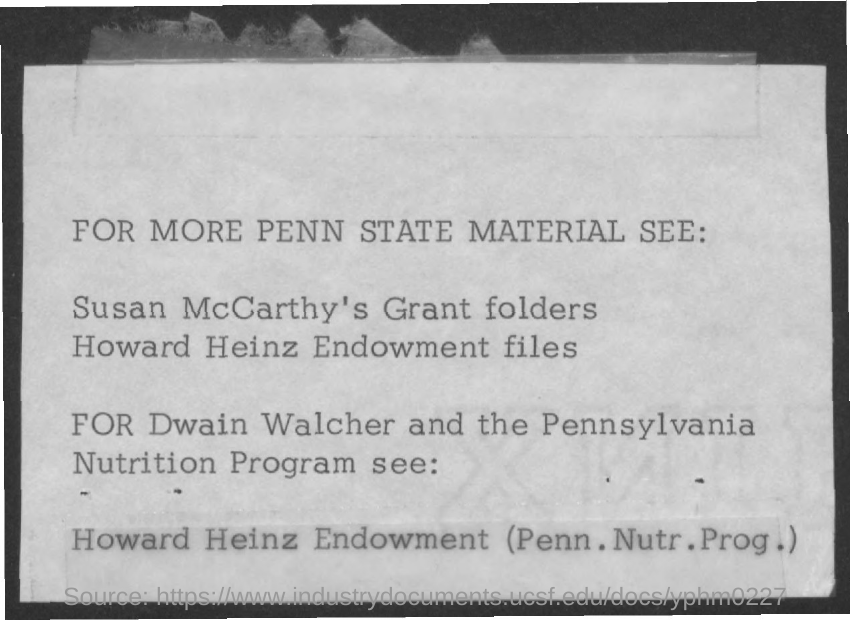What is the first title in the document?
Provide a short and direct response. For more penn state material see:. 